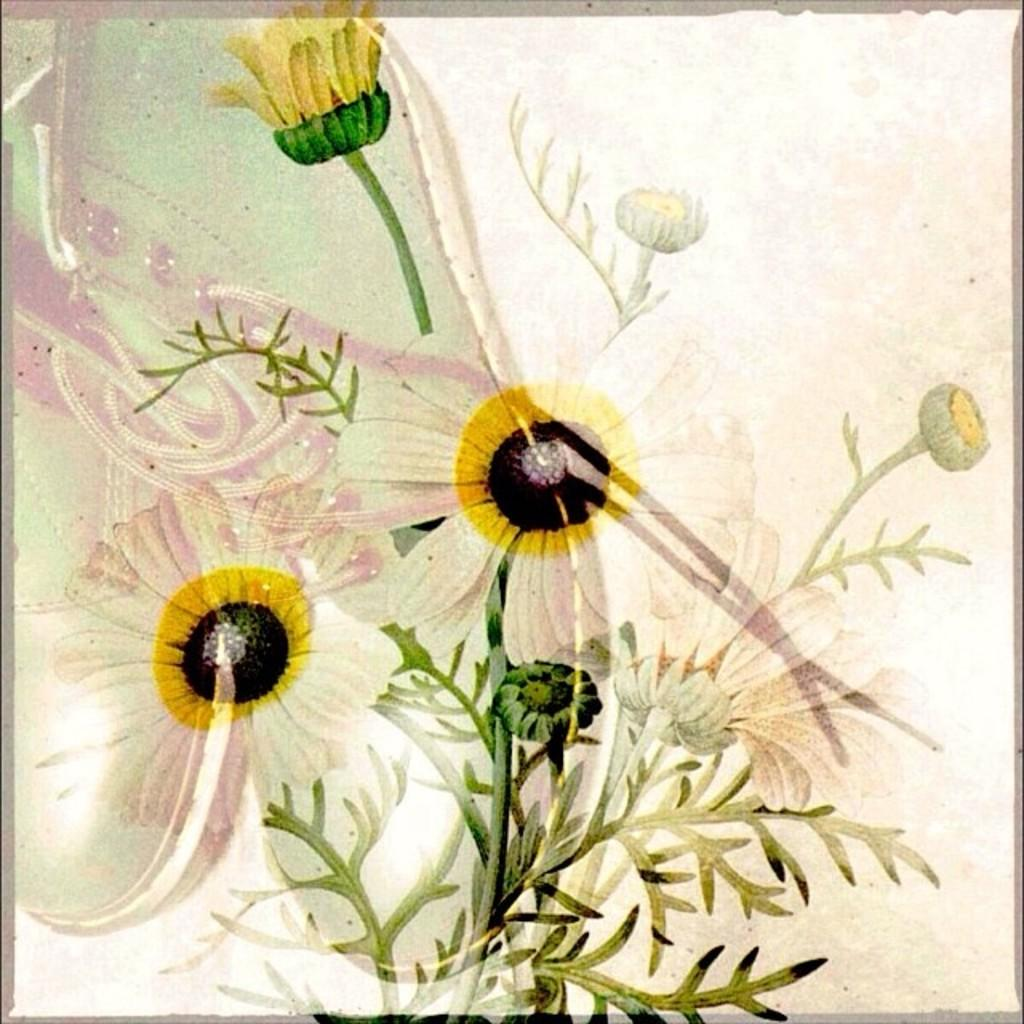What type of living organisms are present in the image? The image contains flowers. What colors can be seen in the flowers? The flowers are in white and pink colors. What else is featured in the middle of the image besides the flowers? There is a picture of a shoe in the middle of the image. Can you tell me how many students are involved in the fight depicted in the image? There is no fight or students present in the image; it features flowers and a picture of a shoe. What type of wilderness can be seen in the background of the image? There is no wilderness visible in the image; it contains flowers and a picture of a shoe. 